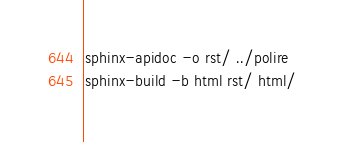<code> <loc_0><loc_0><loc_500><loc_500><_Bash_>sphinx-apidoc -o rst/ ../polire
sphinx-build -b html rst/ html/
</code> 